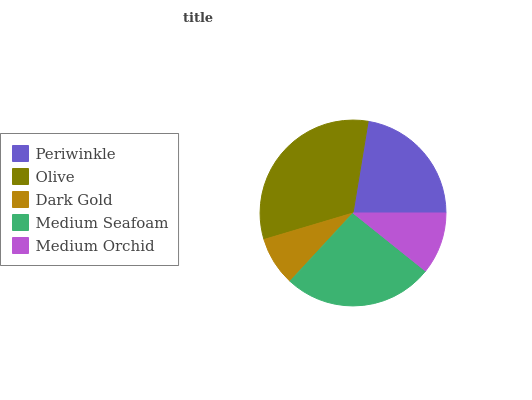Is Dark Gold the minimum?
Answer yes or no. Yes. Is Olive the maximum?
Answer yes or no. Yes. Is Olive the minimum?
Answer yes or no. No. Is Dark Gold the maximum?
Answer yes or no. No. Is Olive greater than Dark Gold?
Answer yes or no. Yes. Is Dark Gold less than Olive?
Answer yes or no. Yes. Is Dark Gold greater than Olive?
Answer yes or no. No. Is Olive less than Dark Gold?
Answer yes or no. No. Is Periwinkle the high median?
Answer yes or no. Yes. Is Periwinkle the low median?
Answer yes or no. Yes. Is Medium Seafoam the high median?
Answer yes or no. No. Is Olive the low median?
Answer yes or no. No. 